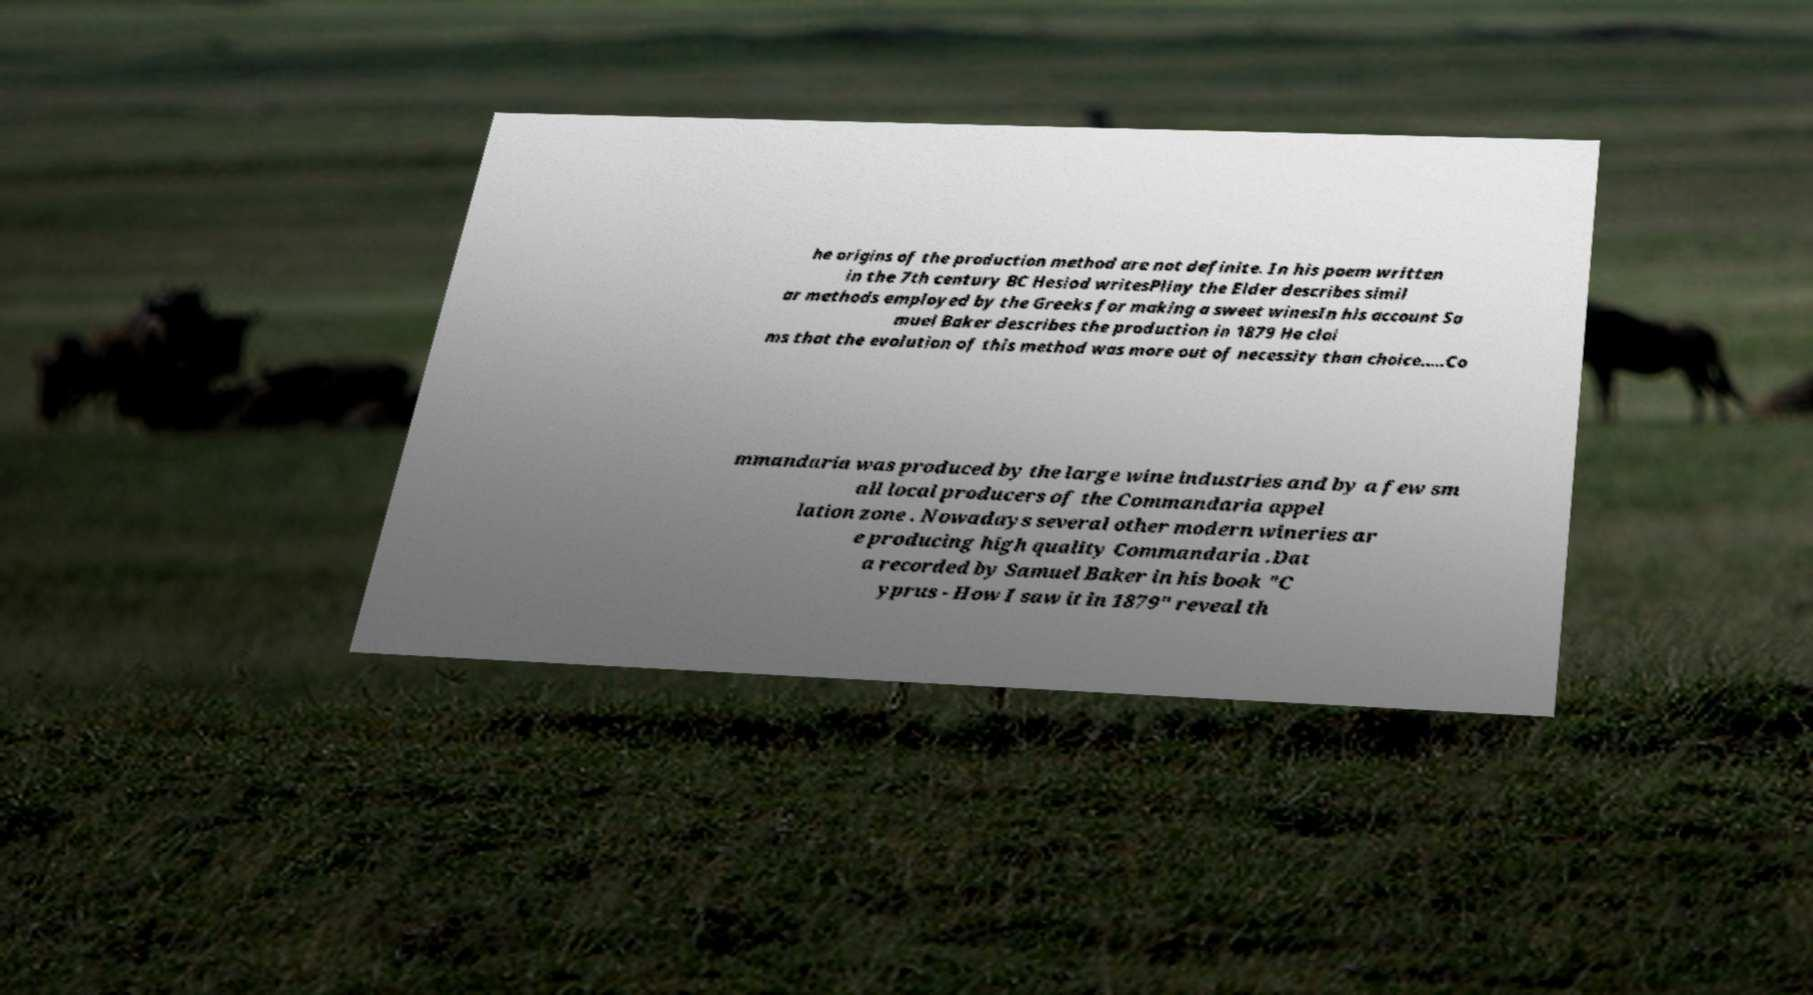Can you read and provide the text displayed in the image?This photo seems to have some interesting text. Can you extract and type it out for me? he origins of the production method are not definite. In his poem written in the 7th century BC Hesiod writesPliny the Elder describes simil ar methods employed by the Greeks for making a sweet winesIn his account Sa muel Baker describes the production in 1879 He clai ms that the evolution of this method was more out of necessity than choice..…Co mmandaria was produced by the large wine industries and by a few sm all local producers of the Commandaria appel lation zone . Nowadays several other modern wineries ar e producing high quality Commandaria .Dat a recorded by Samuel Baker in his book "C yprus - How I saw it in 1879" reveal th 